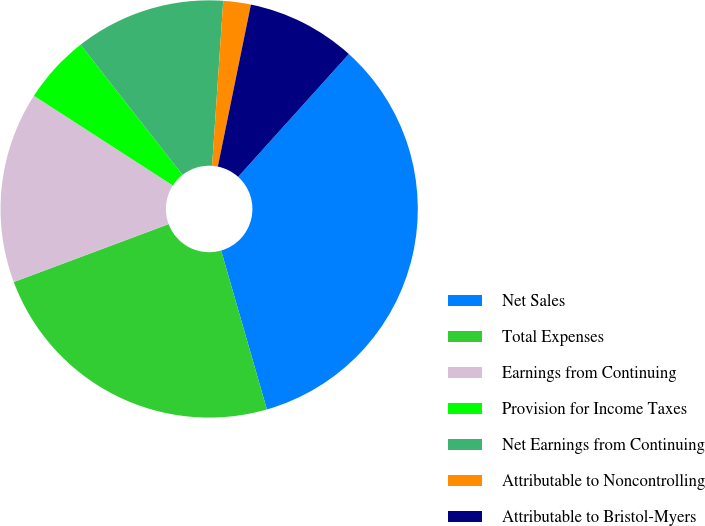<chart> <loc_0><loc_0><loc_500><loc_500><pie_chart><fcel>Net Sales<fcel>Total Expenses<fcel>Earnings from Continuing<fcel>Provision for Income Taxes<fcel>Net Earnings from Continuing<fcel>Attributable to Noncontrolling<fcel>Attributable to Bristol-Myers<nl><fcel>33.86%<fcel>23.77%<fcel>14.82%<fcel>5.3%<fcel>11.65%<fcel>2.13%<fcel>8.47%<nl></chart> 